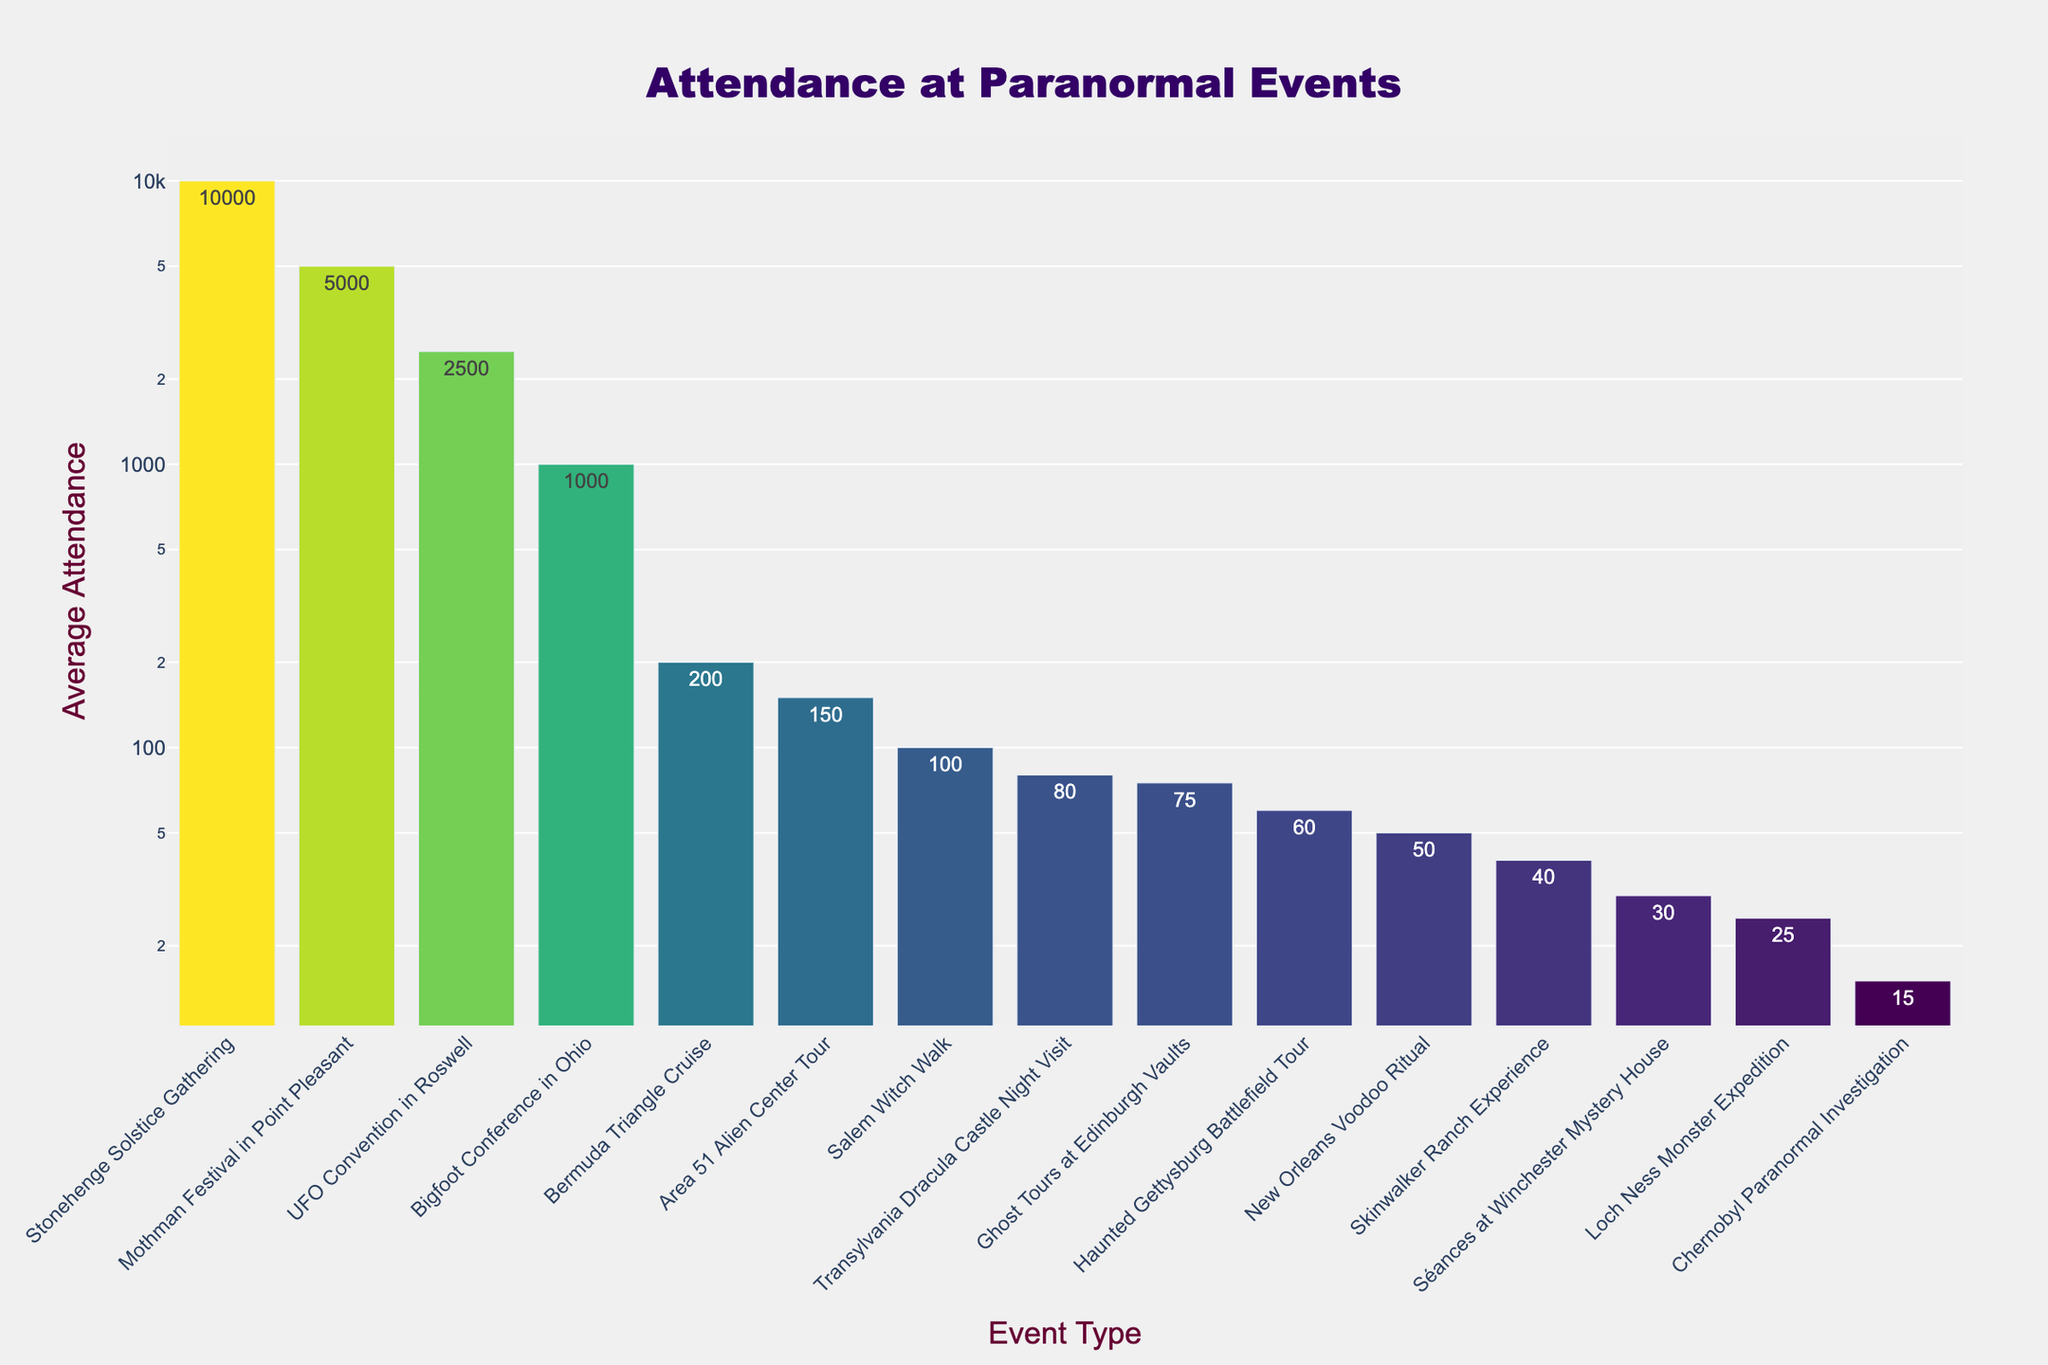What's the event with the highest average attendance? The event with the highest bar represents the one with the highest average attendance. Looking at the figure, the tallest bar is for the "Stonehenge Solstice Gathering."
Answer: Stonehenge Solstice Gathering Which two events have the lowest attendance and what are their average attendances? The two shortest bars indicate the events with the lowest attendance. These are "Chernobyl Paranormal Investigation" and "Loch Ness Monster Expedition," with attendance values of 15 and 25, respectively.
Answer: Chernobyl Paranormal Investigation (15), Loch Ness Monster Expedition (25) How much greater is the average attendance of the Mothman Festival compared to the Salem Witch Walk? Find the heights of the bars for the Mothman Festival and the Salem Witch Walk. The Mothman Festival has an attendance of 5000, and the Salem Witch Walk has 100. The difference is 5000 - 100 = 4900.
Answer: 4900 What's the combined average attendance for all events held in Europe? Identify the events held in Europe and sum their attendance values. Europe-based events include "Ghost Tours at Edinburgh Vaults" (75), "Séances at Winchester Mystery House" (30), "Transylvania Dracula Castle Night Visit" (80), and "Stonehenge Solstice Gathering" (10000). Adding them gives 75 + 30 + 80 + 10000 = 10185.
Answer: 10185 How does the average attendance of the New Orleans Voodoo Ritual compare to the average attendance of a Séance at Winchester Mystery House? Compare the heights of the bars for both events. The average attendance for the New Orleans Voodoo Ritual is 50, and for the Séance at Winchester Mystery House, it's 30. Since 50 > 30, the Voodoo Ritual has a higher attendance.
Answer: New Orleans Voodoo Ritual has a higher attendance What's the average attendance for events that have less than 100 attendees? Identify events with less than 100 attendees and compute their average. These events are "Ghost Tours at Edinburgh Vaults" (75), "Séances at Winchester Mystery House" (30), "Haunted Gettysburg Battlefield Tour" (60), "Skinwalker Ranch Experience" (40), "Loch Ness Monster Expedition" (25), "New Orleans Voodoo Ritual" (50), and "Chernobyl Paranormal Investigation" (15). Their total attendance is 75 + 30 + 60 + 40 + 25 + 50 + 15 = 295. Divide this by the number of events, 295 / 7 ≈ 42.14.
Answer: 42.14 Which event has an attendance closest to the median value of all events? To find the median, first list the attendance values in ascending order: 15, 25, 30, 40, 50, 60, 75, 80, 100, 100, 150, 200, 1000, 2500, 5000, 10000. The median of 16 values is the average of the 8th and 9th values, (75 + 80) / 2 = 77.5. The event "Transylvania Dracula Castle Night Visit" (80) is the closest.
Answer: Transylvania Dracula Castle Night Visit What is the range of average attendance values across all events? The range is the difference between the maximum and minimum values. The maximum attendance is 10000 (Stonehenge Solstice Gathering), and the minimum is 15 (Chernobyl Paranormal Investigation). The range is 10000 - 15 = 9985.
Answer: 9985 